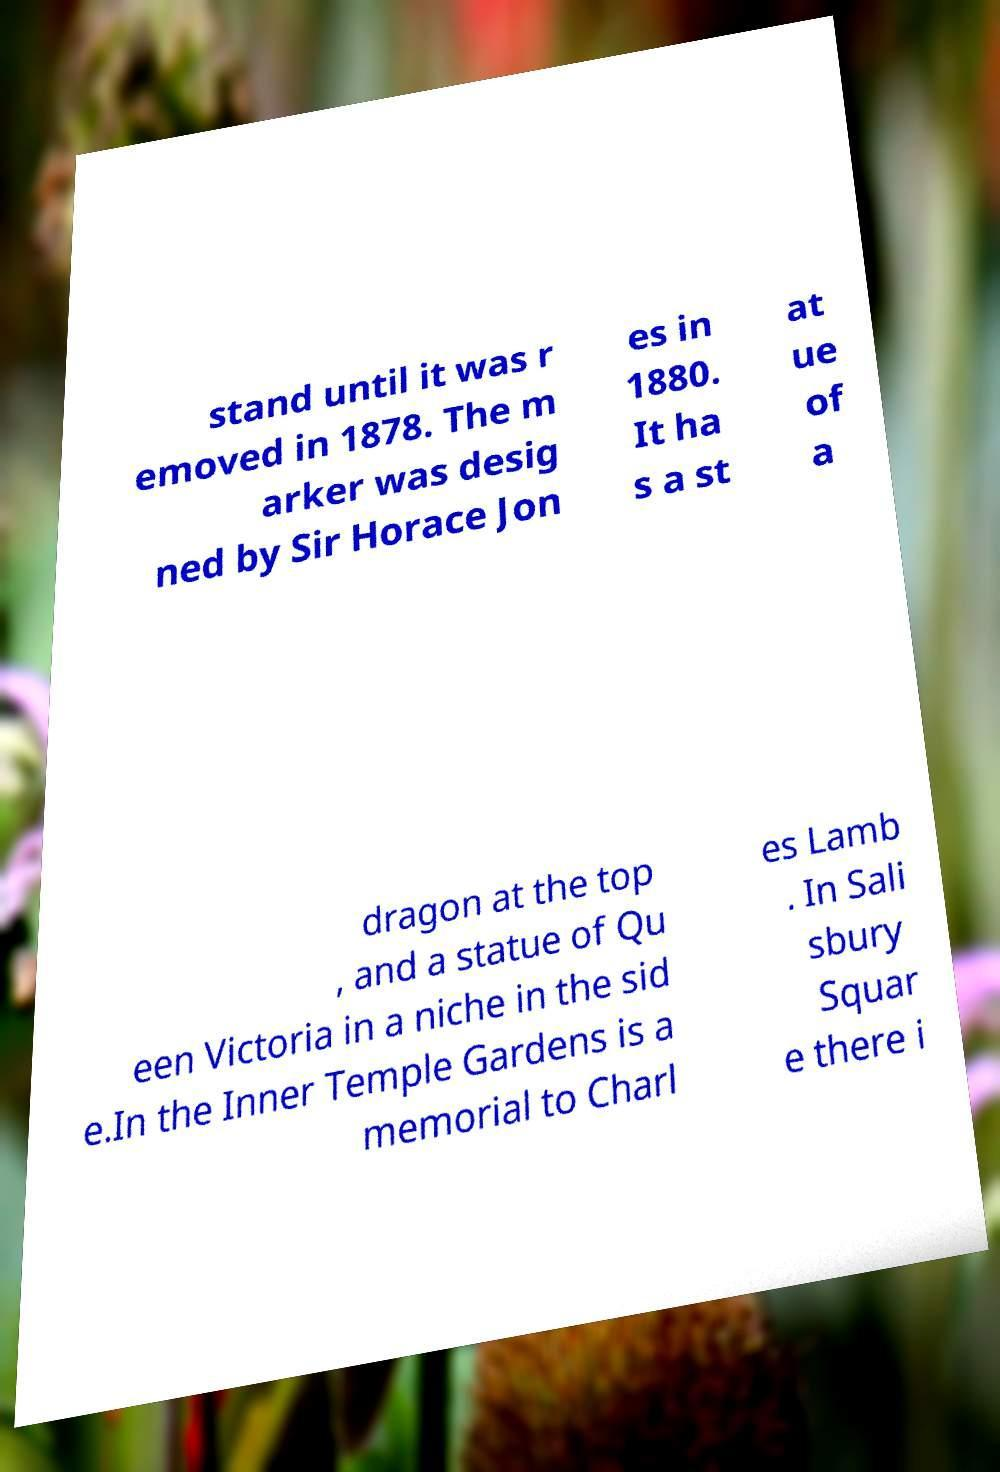Can you read and provide the text displayed in the image?This photo seems to have some interesting text. Can you extract and type it out for me? stand until it was r emoved in 1878. The m arker was desig ned by Sir Horace Jon es in 1880. It ha s a st at ue of a dragon at the top , and a statue of Qu een Victoria in a niche in the sid e.In the Inner Temple Gardens is a memorial to Charl es Lamb . In Sali sbury Squar e there i 